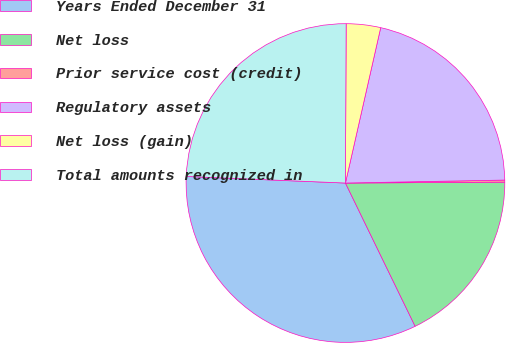<chart> <loc_0><loc_0><loc_500><loc_500><pie_chart><fcel>Years Ended December 31<fcel>Net loss<fcel>Prior service cost (credit)<fcel>Regulatory assets<fcel>Net loss (gain)<fcel>Total amounts recognized in<nl><fcel>32.86%<fcel>17.88%<fcel>0.21%<fcel>21.15%<fcel>3.48%<fcel>24.41%<nl></chart> 